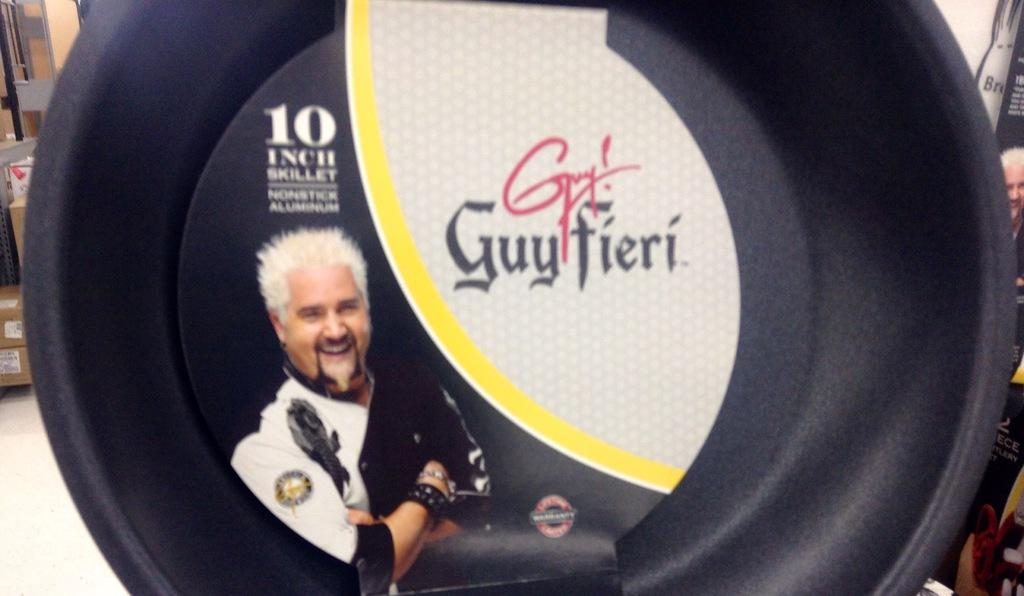What is: What is the main subject of the image? There is a black object in the image. What can be observed on the black object? The black object has a label. What is depicted on the label? The label contains a person's image and some text. What can be seen in the background of the image? There are objects visible in the background of the image. Can you tell me how many grapes are on the pen in the image? There is no pen or grapes present in the image. What type of push can be seen in the image? There is no push or pushing action depicted in the image. 